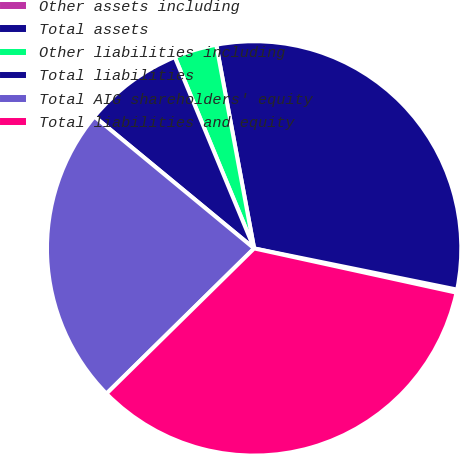<chart> <loc_0><loc_0><loc_500><loc_500><pie_chart><fcel>Other assets including<fcel>Total assets<fcel>Other liabilities including<fcel>Total liabilities<fcel>Total AIG shareholders' equity<fcel>Total liabilities and equity<nl><fcel>0.24%<fcel>31.11%<fcel>3.33%<fcel>7.76%<fcel>23.35%<fcel>34.2%<nl></chart> 